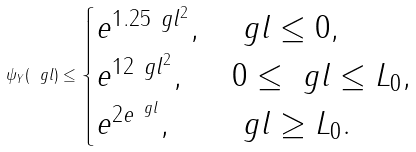Convert formula to latex. <formula><loc_0><loc_0><loc_500><loc_500>\psi _ { Y } ( \ g l ) \leq \begin{cases} e ^ { 1 . 2 5 \ g l ^ { 2 } } , & \ g l \leq 0 , \\ e ^ { 1 2 \ g l ^ { 2 } } , & 0 \leq \ g l \leq L _ { 0 } , \\ e ^ { 2 e ^ { \ g l } } , & \ g l \geq L _ { 0 } . \end{cases}</formula> 